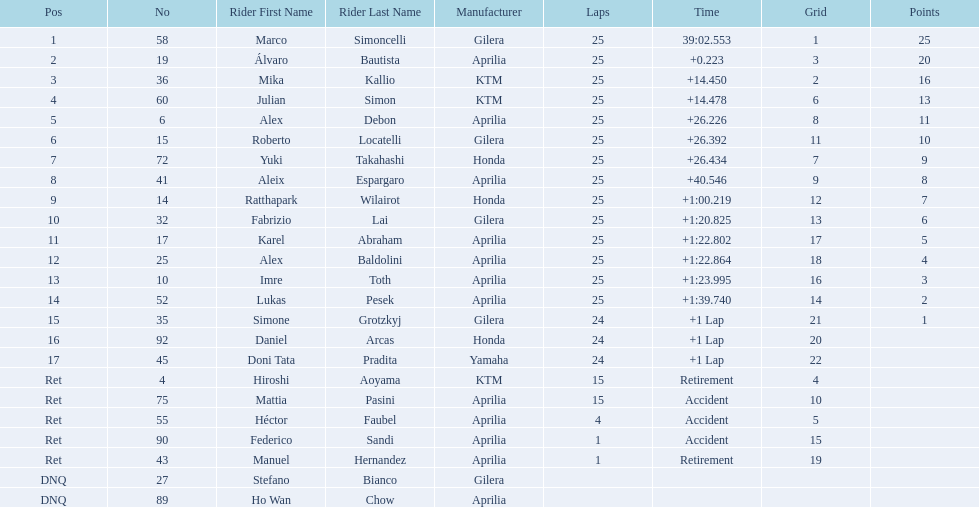Who are all the riders? Marco Simoncelli, Álvaro Bautista, Mika Kallio, Julian Simon, Alex Debon, Roberto Locatelli, Yuki Takahashi, Aleix Espargaro, Ratthapark Wilairot, Fabrizio Lai, Karel Abraham, Alex Baldolini, Imre Toth, Lukas Pesek, Simone Grotzkyj, Daniel Arcas, Doni Tata Pradita, Hiroshi Aoyama, Mattia Pasini, Héctor Faubel, Federico Sandi, Manuel Hernandez, Stefano Bianco, Ho Wan Chow. Which held rank 1? Marco Simoncelli. 